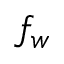<formula> <loc_0><loc_0><loc_500><loc_500>f _ { w }</formula> 